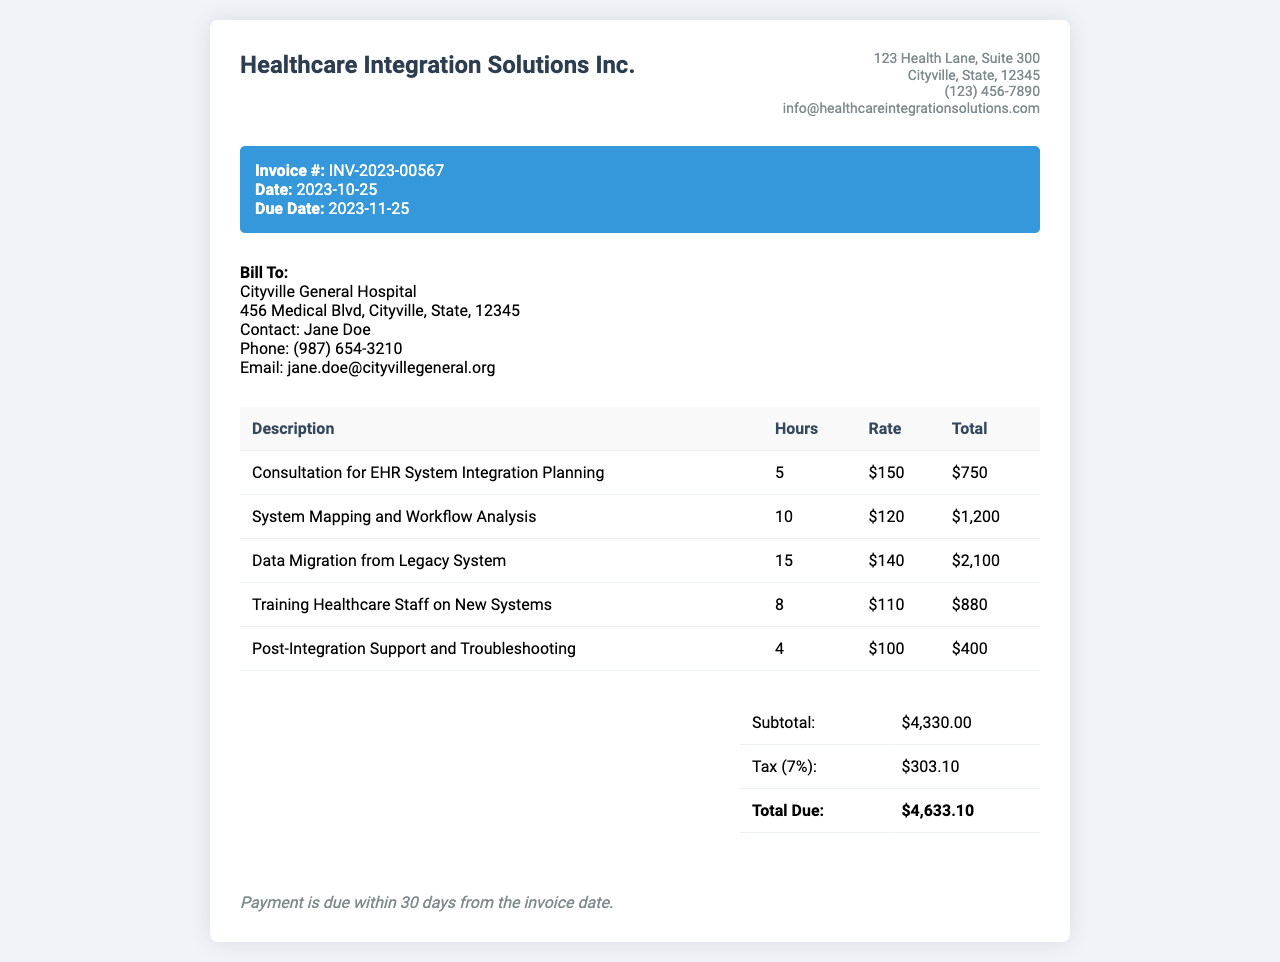What is the invoice number? The invoice number is listed in the invoice details section.
Answer: INV-2023-00567 What is the invoice date? The invoice date is the date the invoice was issued, found in the invoice details section.
Answer: 2023-10-25 Who is the client contact? The client contact is specified in the client information section of the invoice.
Answer: Jane Doe What is the subtotal amount? The subtotal is shown in the summary table as part of the financial breakdown.
Answer: $4,330.00 How many hours were spent on data migration? The hours spent on data migration is provided in the description of services.
Answer: 15 What is the tax rate applied to the invoice? The tax rate can be found in the summary of financial details within the document.
Answer: 7% What is the total due? The total due is highlighted in the summary table at the end of the invoice.
Answer: $4,633.10 What service required the most hours? The service with the highest hours is indicated in the services table.
Answer: Data Migration from Legacy System What was the rate for training healthcare staff? The rate for training healthcare staff is specified in the services table alongside the hours worked.
Answer: $110 